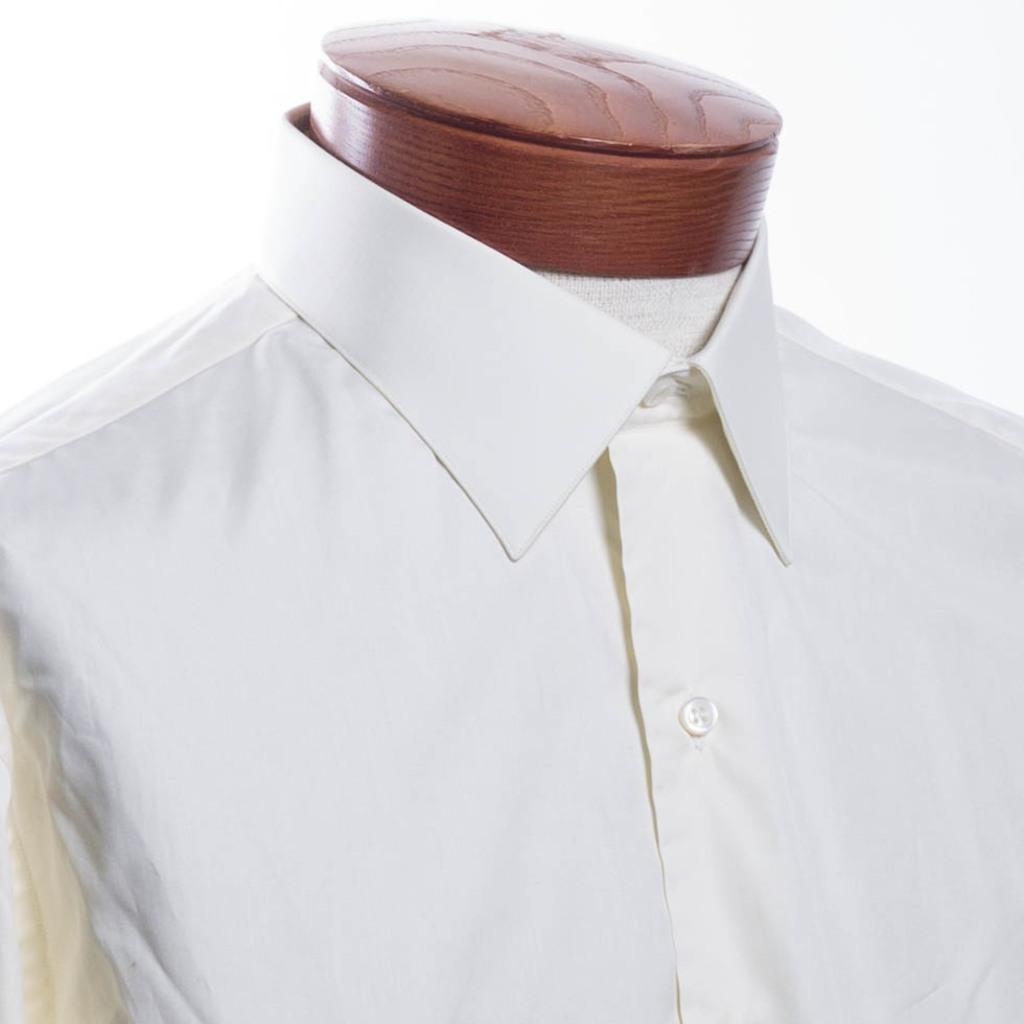What type of clothing item is in the image? There is a white color shirt in the image. Where is the shirt located? The shirt is on a mannequin. What color is the background of the image? The background of the image is white in color. Can you compare the clouds in the image to the cow in the field? There are no clouds or cows present in the image; it only features a white color shirt on a mannequin with a white background. 